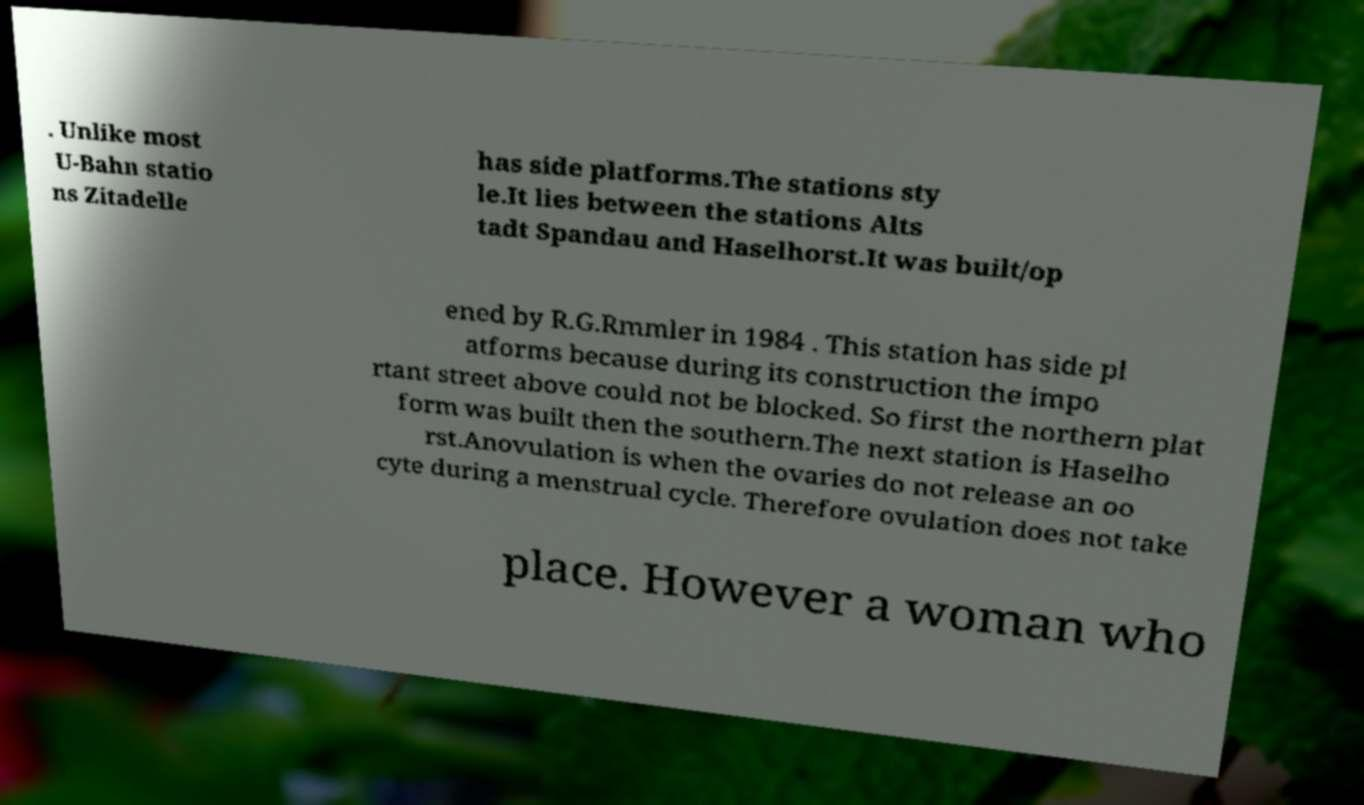Could you assist in decoding the text presented in this image and type it out clearly? . Unlike most U-Bahn statio ns Zitadelle has side platforms.The stations sty le.It lies between the stations Alts tadt Spandau and Haselhorst.It was built/op ened by R.G.Rmmler in 1984 . This station has side pl atforms because during its construction the impo rtant street above could not be blocked. So first the northern plat form was built then the southern.The next station is Haselho rst.Anovulation is when the ovaries do not release an oo cyte during a menstrual cycle. Therefore ovulation does not take place. However a woman who 